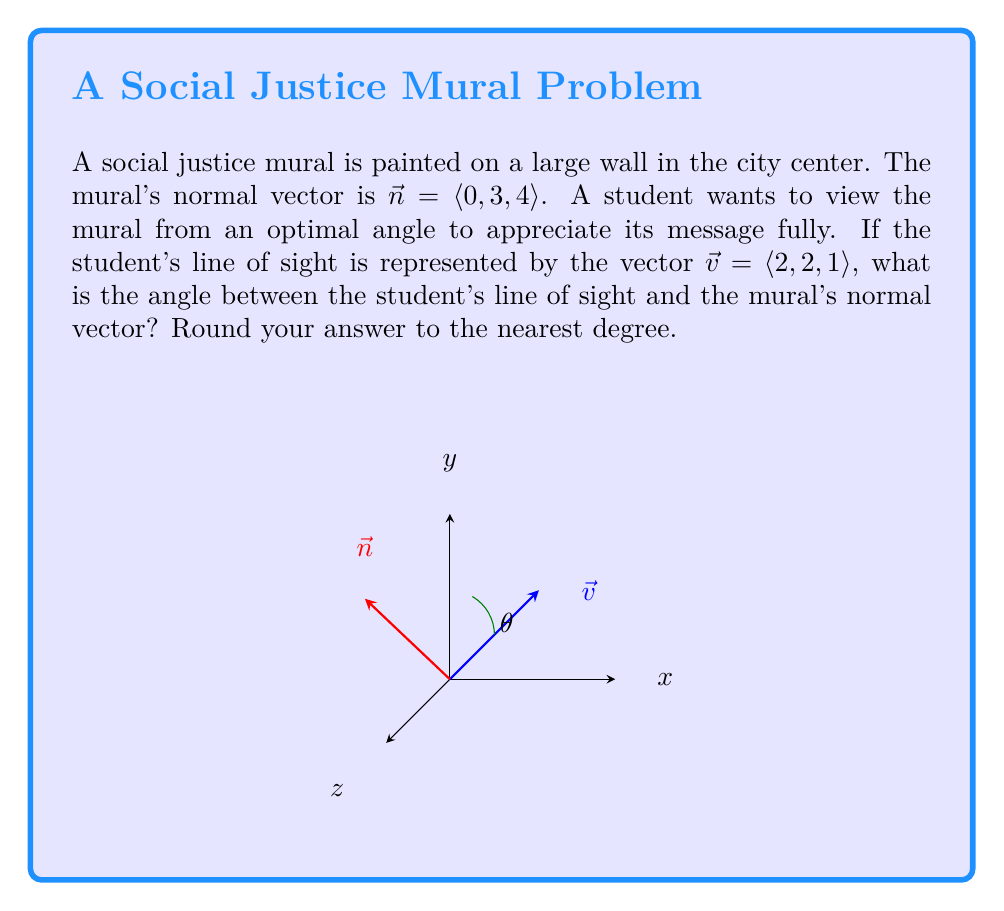Teach me how to tackle this problem. To find the angle between two vectors using dot product, we can use the formula:

$$\cos \theta = \frac{\vec{v} \cdot \vec{n}}{|\vec{v}||\vec{n}|}$$

Step 1: Calculate the dot product $\vec{v} \cdot \vec{n}$
$$\vec{v} \cdot \vec{n} = (2)(0) + (2)(3) + (1)(4) = 0 + 6 + 4 = 10$$

Step 2: Calculate the magnitudes of $\vec{v}$ and $\vec{n}$
$$|\vec{v}| = \sqrt{2^2 + 2^2 + 1^2} = \sqrt{9} = 3$$
$$|\vec{n}| = \sqrt{0^2 + 3^2 + 4^2} = \sqrt{25} = 5$$

Step 3: Substitute into the formula
$$\cos \theta = \frac{10}{3 \cdot 5} = \frac{10}{15} = \frac{2}{3}$$

Step 4: Take the inverse cosine (arccos) of both sides
$$\theta = \arccos(\frac{2}{3}) \approx 48.19^\circ$$

Step 5: Round to the nearest degree
$$\theta \approx 48^\circ$$
Answer: $48^\circ$ 